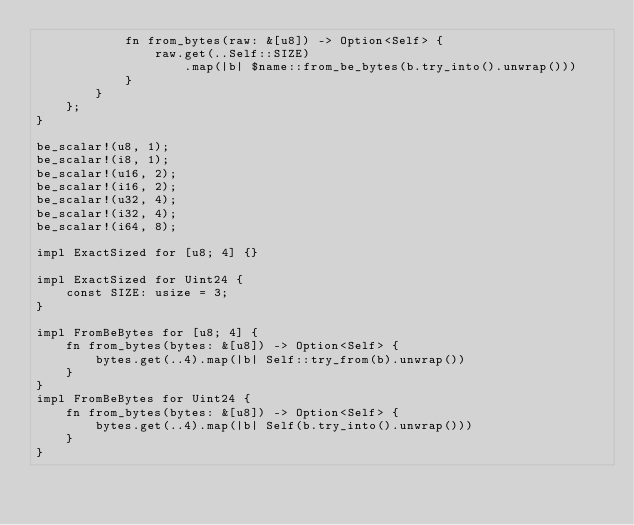Convert code to text. <code><loc_0><loc_0><loc_500><loc_500><_Rust_>            fn from_bytes(raw: &[u8]) -> Option<Self> {
                raw.get(..Self::SIZE)
                    .map(|b| $name::from_be_bytes(b.try_into().unwrap()))
            }
        }
    };
}

be_scalar!(u8, 1);
be_scalar!(i8, 1);
be_scalar!(u16, 2);
be_scalar!(i16, 2);
be_scalar!(u32, 4);
be_scalar!(i32, 4);
be_scalar!(i64, 8);

impl ExactSized for [u8; 4] {}

impl ExactSized for Uint24 {
    const SIZE: usize = 3;
}

impl FromBeBytes for [u8; 4] {
    fn from_bytes(bytes: &[u8]) -> Option<Self> {
        bytes.get(..4).map(|b| Self::try_from(b).unwrap())
    }
}
impl FromBeBytes for Uint24 {
    fn from_bytes(bytes: &[u8]) -> Option<Self> {
        bytes.get(..4).map(|b| Self(b.try_into().unwrap()))
    }
}
</code> 